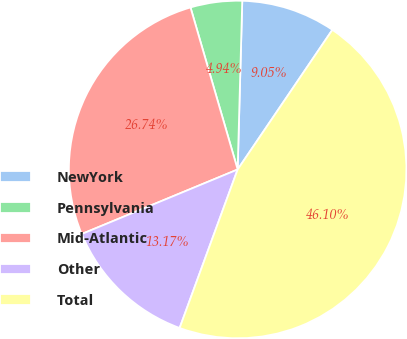Convert chart to OTSL. <chart><loc_0><loc_0><loc_500><loc_500><pie_chart><fcel>NewYork<fcel>Pennsylvania<fcel>Mid-Atlantic<fcel>Other<fcel>Total<nl><fcel>9.05%<fcel>4.94%<fcel>26.74%<fcel>13.17%<fcel>46.1%<nl></chart> 